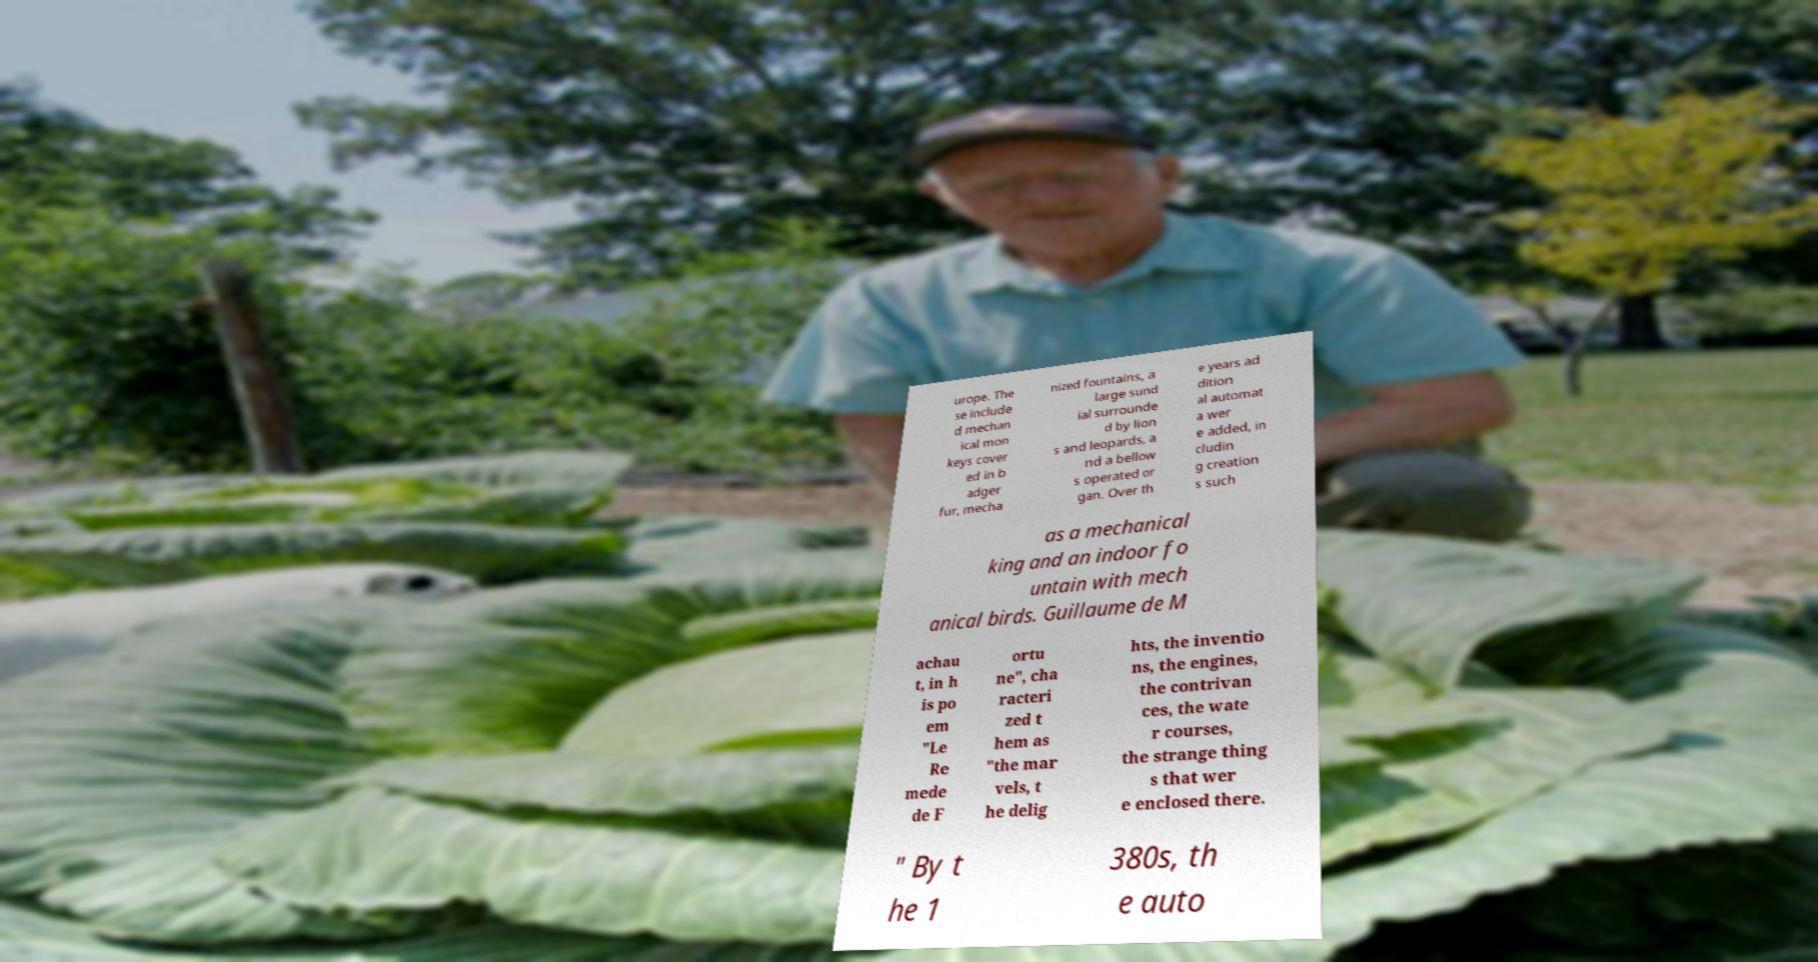Please read and relay the text visible in this image. What does it say? urope. The se include d mechan ical mon keys cover ed in b adger fur, mecha nized fountains, a large sund ial surrounde d by lion s and leopards, a nd a bellow s operated or gan. Over th e years ad dition al automat a wer e added, in cludin g creation s such as a mechanical king and an indoor fo untain with mech anical birds. Guillaume de M achau t, in h is po em "Le Re mede de F ortu ne", cha racteri zed t hem as "the mar vels, t he delig hts, the inventio ns, the engines, the contrivan ces, the wate r courses, the strange thing s that wer e enclosed there. " By t he 1 380s, th e auto 